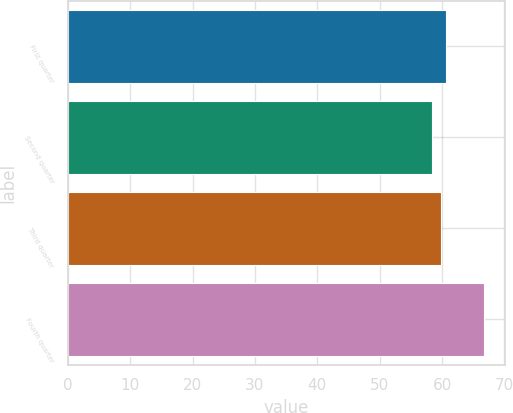Convert chart. <chart><loc_0><loc_0><loc_500><loc_500><bar_chart><fcel>First quarter<fcel>Second quarter<fcel>Third quarter<fcel>Fourth quarter<nl><fcel>60.7<fcel>58.32<fcel>59.86<fcel>66.7<nl></chart> 